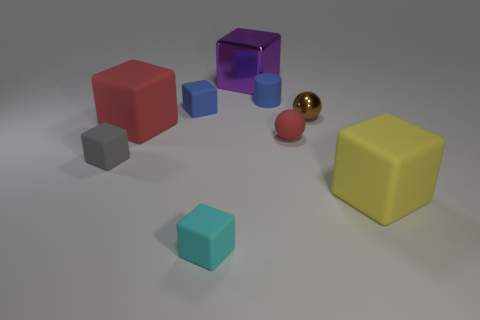Add 1 large red matte blocks. How many objects exist? 10 Subtract all large purple shiny blocks. How many blocks are left? 5 Subtract all red cubes. How many cubes are left? 5 Subtract 5 blocks. How many blocks are left? 1 Subtract all cylinders. How many objects are left? 8 Subtract all blue cubes. Subtract all cyan spheres. How many cubes are left? 5 Subtract all purple balls. How many blue blocks are left? 1 Subtract all tiny gray rubber cubes. Subtract all brown shiny spheres. How many objects are left? 7 Add 2 blue cylinders. How many blue cylinders are left? 3 Add 6 tiny blue metallic things. How many tiny blue metallic things exist? 6 